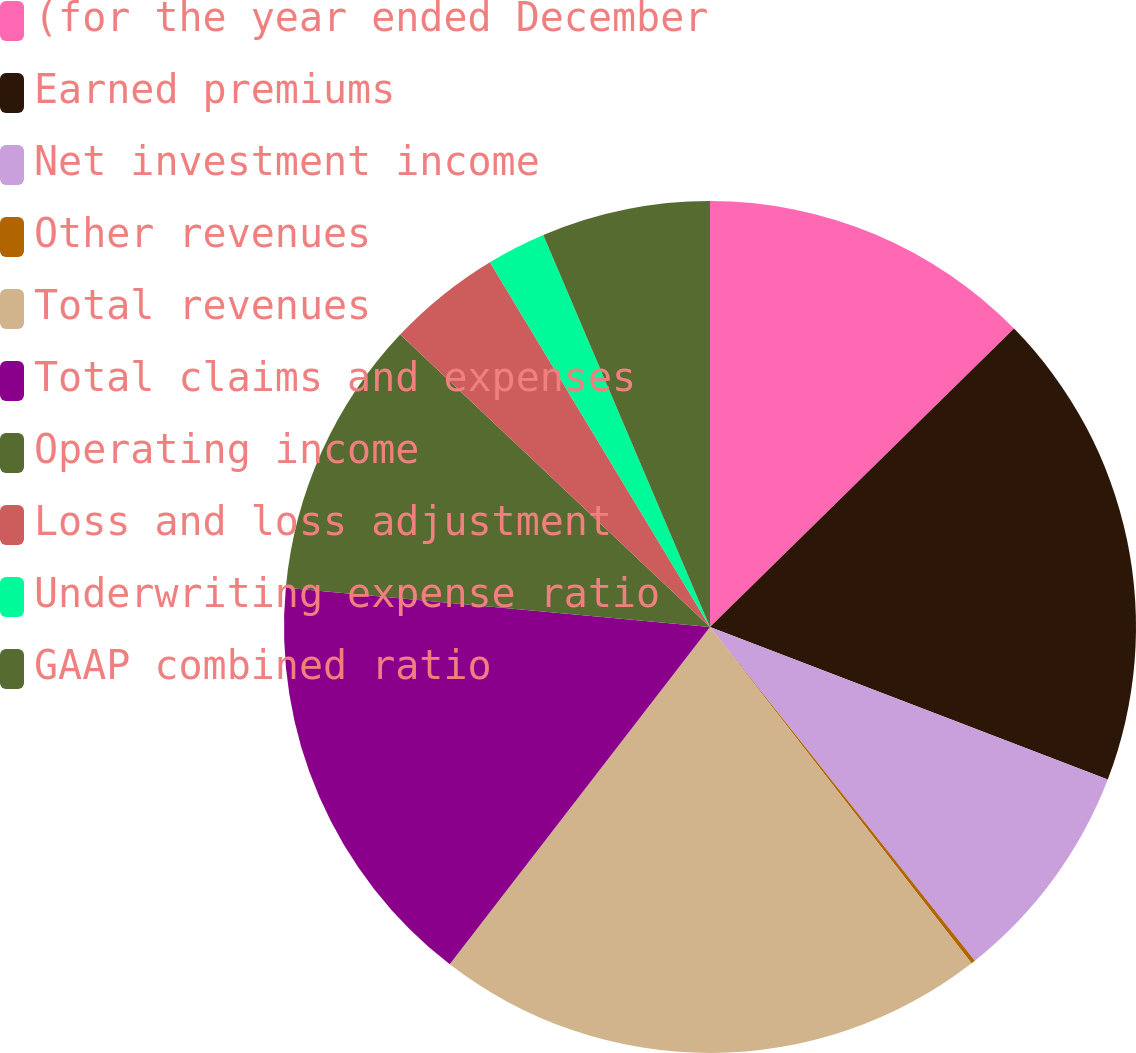<chart> <loc_0><loc_0><loc_500><loc_500><pie_chart><fcel>(for the year ended December<fcel>Earned premiums<fcel>Net investment income<fcel>Other revenues<fcel>Total revenues<fcel>Total claims and expenses<fcel>Operating income<fcel>Loss and loss adjustment<fcel>Underwriting expense ratio<fcel>GAAP combined ratio<nl><fcel>12.65%<fcel>18.18%<fcel>8.49%<fcel>0.16%<fcel>20.98%<fcel>16.01%<fcel>10.57%<fcel>4.32%<fcel>2.24%<fcel>6.4%<nl></chart> 